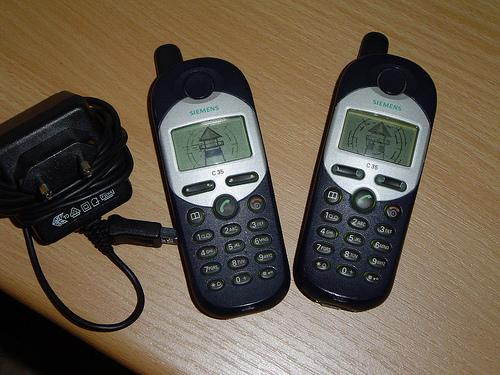Provide a brief description of the main objects in the image. Two black cellphones on a brown wooden table, a black cell phone charger, and buttons with green and red letters and symbols. Highlight the key elements of the image in a single sentence. A pair of black identical cellphones with radio logos, buttons, and numbers on a brown wooden table, accompanied by a black charger. Provide a summary of the objects and their main characteristics in the image. Two black cellphones with green logos and various buttons sit on a brown wooden table, alongside a large black charger with white symbols. Mention the most noticeable features of the cellphones on the table. The cellphones have various buttons with numbers and green symbols, a gray top, and green-colored radio logos. Write a short sentence on the appearance of the table in the image. A brown, wooden table with a glossy surface showcasing two cellphones and a charger. Point out what is unique about the buttons on the cellphones. The middle buttons have a green phone symbol, and some of the buttons feature red and green letters. State the main colors and materials seen in the image. Black (cell phones and charger), brown (wooden table), green (logos and call buttons), gray (top part of phones), and red (button). Mention the primary color and object combinations found in the image. Black cellphones with green logos, brown wooden table, and black charger with white symbols. Describe the key details about the charger in the image. A large black charger with USB on the end, showing white symbols on its surface. Describe the setup of the objects in the image. Two identical cellphones are placed side by side on a brown wooden table, next to a black charger with a USB end. 